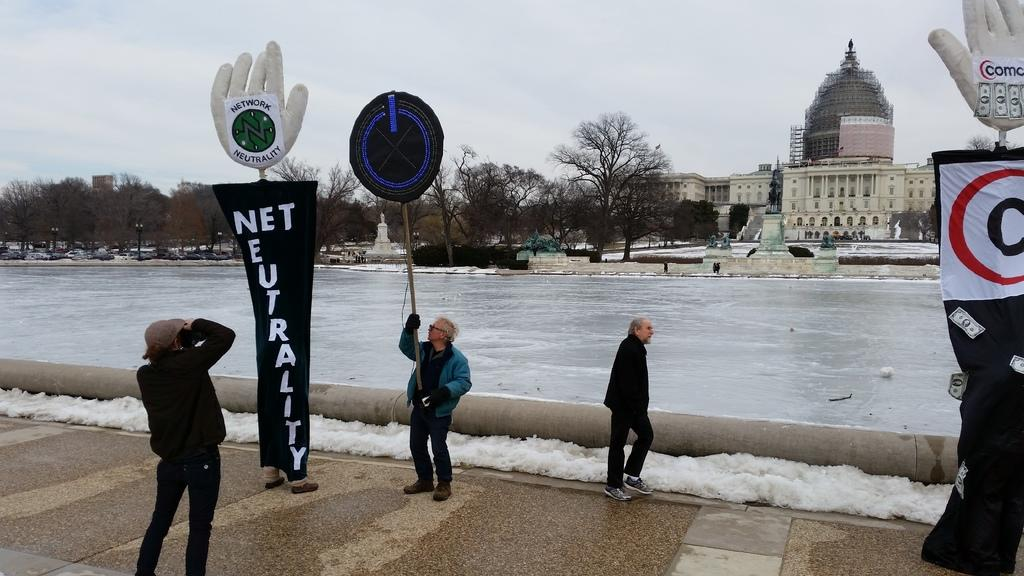Provide a one-sentence caption for the provided image. A person taking a picture of a man holding up a sign next to a sign that says Net Neutrality. 